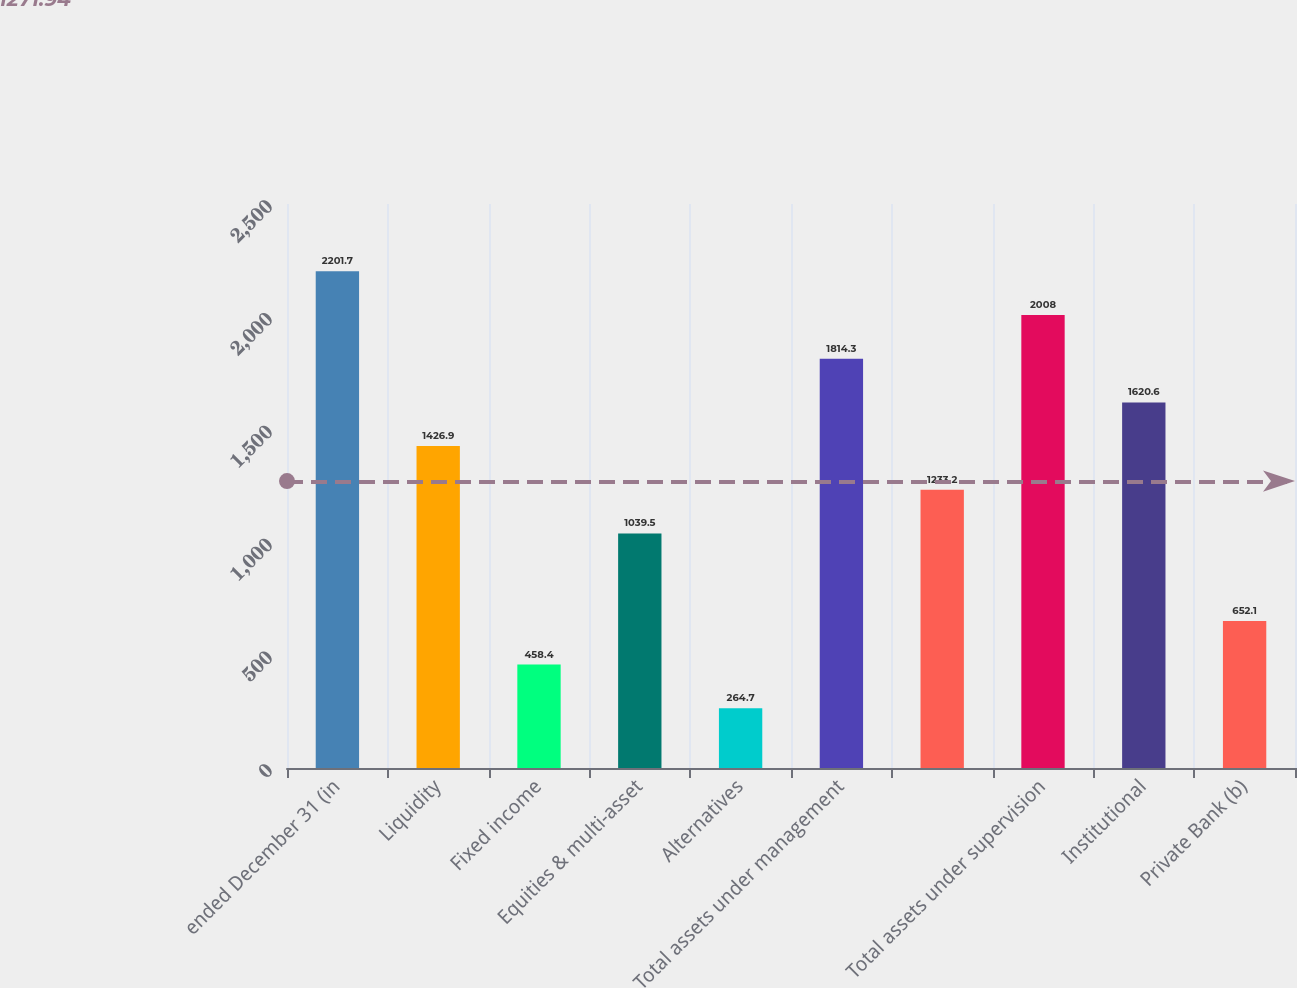<chart> <loc_0><loc_0><loc_500><loc_500><bar_chart><fcel>ended December 31 (in<fcel>Liquidity<fcel>Fixed income<fcel>Equities & multi-asset<fcel>Alternatives<fcel>Total assets under management<fcel>Unnamed: 6<fcel>Total assets under supervision<fcel>Institutional<fcel>Private Bank (b)<nl><fcel>2201.7<fcel>1426.9<fcel>458.4<fcel>1039.5<fcel>264.7<fcel>1814.3<fcel>1233.2<fcel>2008<fcel>1620.6<fcel>652.1<nl></chart> 